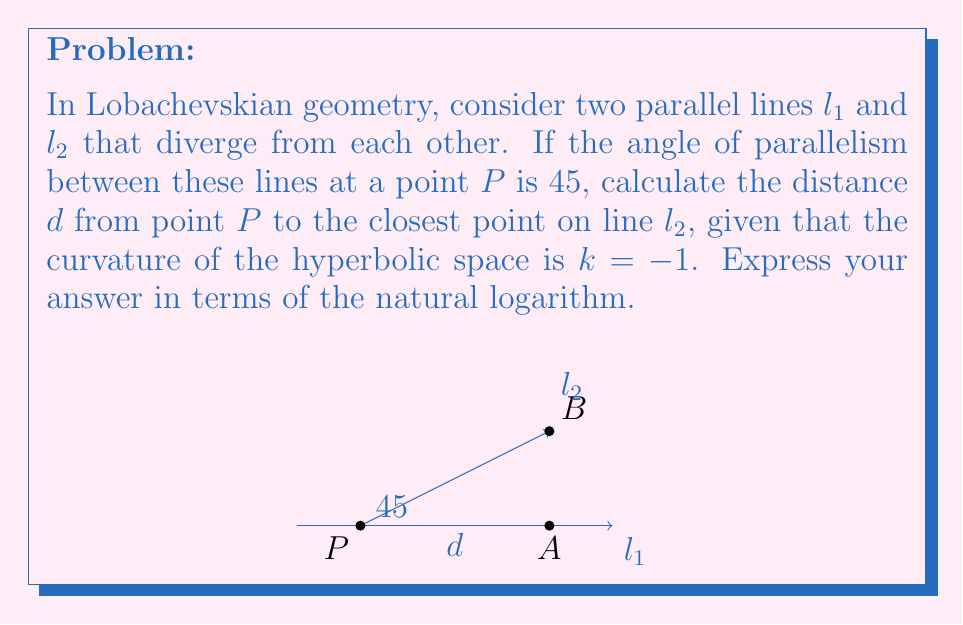What is the answer to this math problem? Let's approach this step-by-step:

1) In Lobachevskian geometry, the angle of parallelism $\Pi(d)$ is related to the distance $d$ by the formula:

   $$\tan(\frac{\Pi(d)}{2}) = e^{-d\sqrt{-k}}$$

2) We're given that the angle of parallelism is $45°$ and $k=-1$. Let's substitute these values:

   $$\tan(\frac{45°}{2}) = e^{-d\sqrt{1}}$$

3) Simplify the left side:

   $$\tan(22.5°) = e^{-d}$$

4) The tangent of $22.5°$ is $\sqrt{2} - 1$. So we have:

   $$\sqrt{2} - 1 = e^{-d}$$

5) Take the natural logarithm of both sides:

   $$\ln(\sqrt{2} - 1) = -d$$

6) Solve for $d$:

   $$d = -\ln(\sqrt{2} - 1)$$

7) This can be simplified further:

   $$d = \ln(\sqrt{2} + 1)$$

This is because $(\sqrt{2} + 1)(\sqrt{2} - 1) = 1$, so $\frac{1}{\sqrt{2} - 1} = \sqrt{2} + 1$.
Answer: $d = \ln(\sqrt{2} + 1)$ 